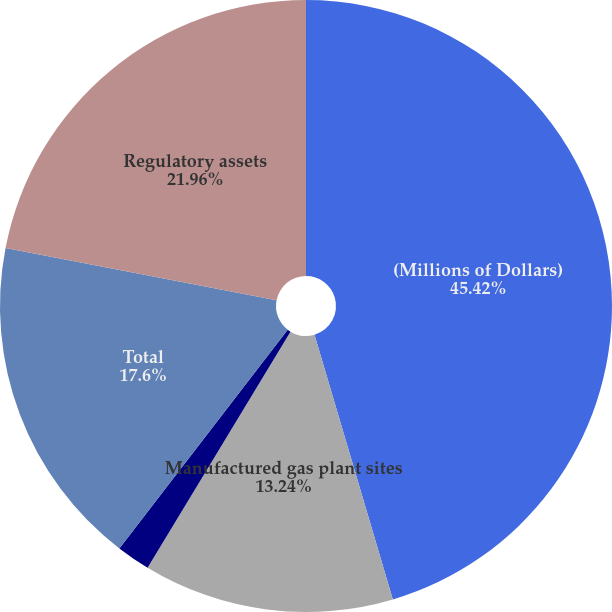<chart> <loc_0><loc_0><loc_500><loc_500><pie_chart><fcel>(Millions of Dollars)<fcel>Manufactured gas plant sites<fcel>Other Superfund Sites<fcel>Total<fcel>Regulatory assets<nl><fcel>45.42%<fcel>13.24%<fcel>1.78%<fcel>17.6%<fcel>21.96%<nl></chart> 